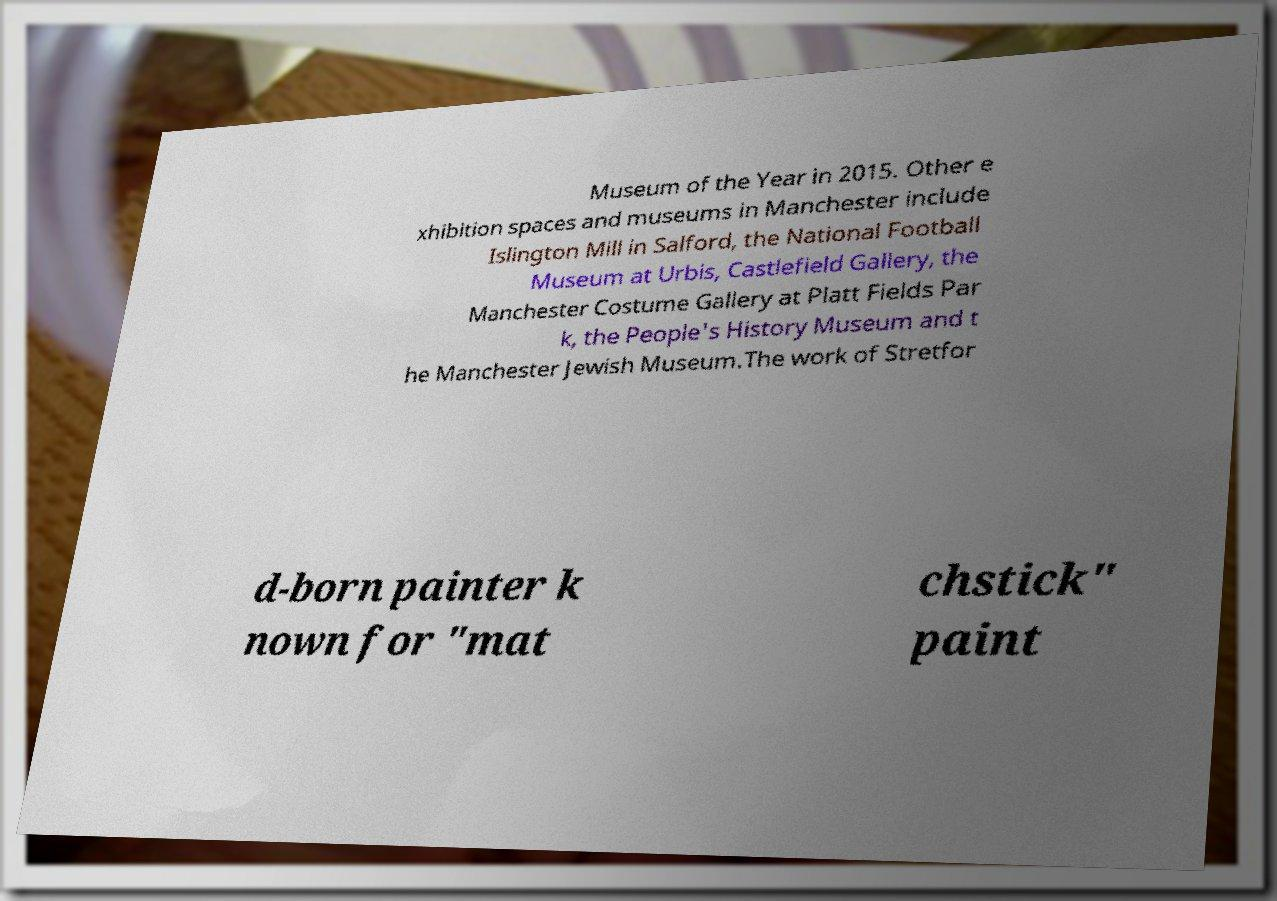Can you accurately transcribe the text from the provided image for me? Museum of the Year in 2015. Other e xhibition spaces and museums in Manchester include Islington Mill in Salford, the National Football Museum at Urbis, Castlefield Gallery, the Manchester Costume Gallery at Platt Fields Par k, the People's History Museum and t he Manchester Jewish Museum.The work of Stretfor d-born painter k nown for "mat chstick" paint 